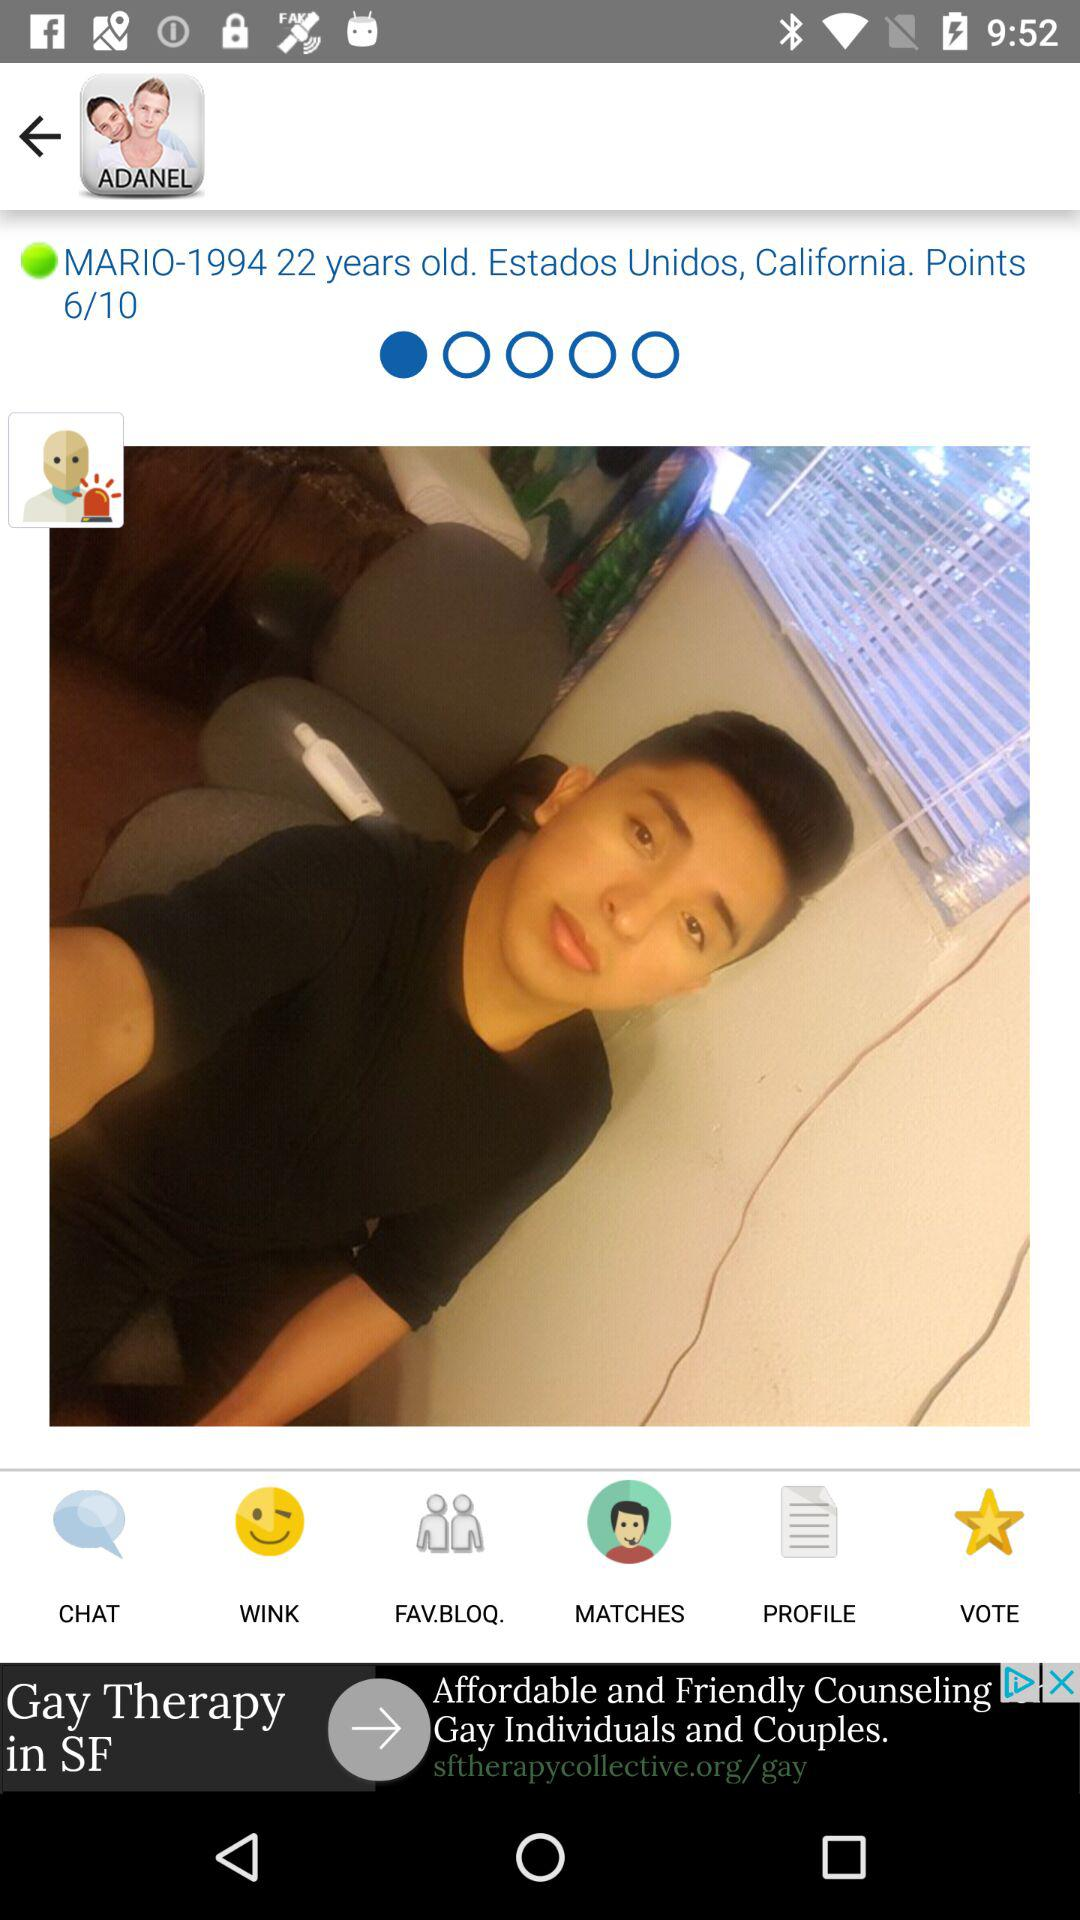What is the user name? The user name is Mario. 